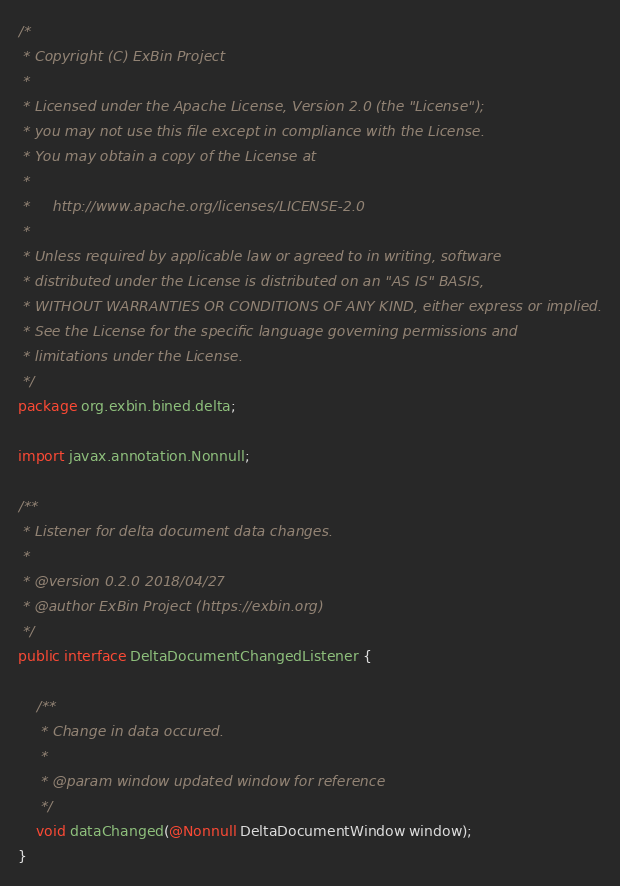<code> <loc_0><loc_0><loc_500><loc_500><_Java_>/*
 * Copyright (C) ExBin Project
 *
 * Licensed under the Apache License, Version 2.0 (the "License");
 * you may not use this file except in compliance with the License.
 * You may obtain a copy of the License at
 *
 *     http://www.apache.org/licenses/LICENSE-2.0
 *
 * Unless required by applicable law or agreed to in writing, software
 * distributed under the License is distributed on an "AS IS" BASIS,
 * WITHOUT WARRANTIES OR CONDITIONS OF ANY KIND, either express or implied.
 * See the License for the specific language governing permissions and
 * limitations under the License.
 */
package org.exbin.bined.delta;

import javax.annotation.Nonnull;

/**
 * Listener for delta document data changes.
 *
 * @version 0.2.0 2018/04/27
 * @author ExBin Project (https://exbin.org)
 */
public interface DeltaDocumentChangedListener {

    /**
     * Change in data occured.
     *
     * @param window updated window for reference
     */
    void dataChanged(@Nonnull DeltaDocumentWindow window);
}
</code> 